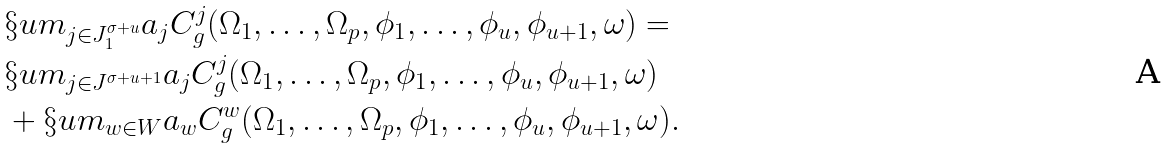<formula> <loc_0><loc_0><loc_500><loc_500>& \S u m _ { j \in J ^ { \sigma + u } _ { 1 } } a _ { j } C ^ { j } _ { g } ( \Omega _ { 1 } , \dots , \Omega _ { p } , \phi _ { 1 } , \dots , \phi _ { u } , \phi _ { u + 1 } , \omega ) = \\ & \S u m _ { j \in J ^ { \sigma + u + 1 } } a _ { j } C ^ { j } _ { g } ( \Omega _ { 1 } , \dots , \Omega _ { p } , \phi _ { 1 } , \dots , \phi _ { u } , \phi _ { u + 1 } , \omega ) \\ & + \S u m _ { w \in W } a _ { w } C ^ { w } _ { g } ( \Omega _ { 1 } , \dots , \Omega _ { p } , \phi _ { 1 } , \dots , \phi _ { u } , \phi _ { u + 1 } , \omega ) .</formula> 